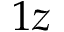Convert formula to latex. <formula><loc_0><loc_0><loc_500><loc_500>1 z</formula> 